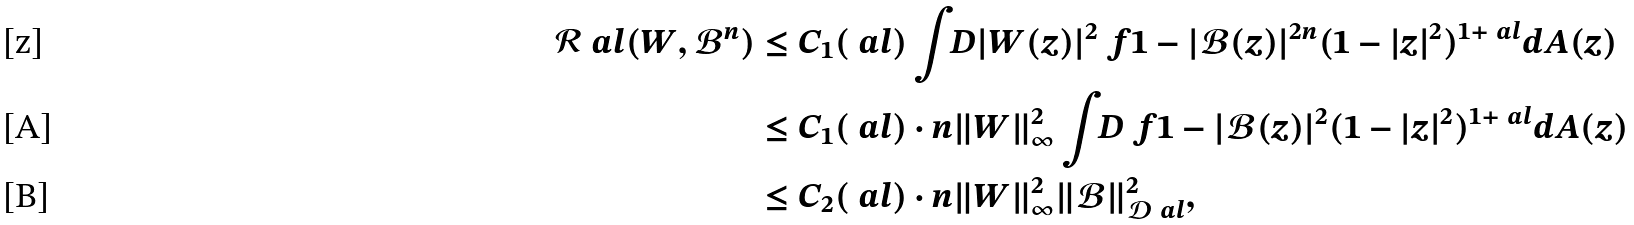Convert formula to latex. <formula><loc_0><loc_0><loc_500><loc_500>\mathcal { R } _ { \ } a l ( W , \mathcal { B } ^ { n } ) & \leq C _ { 1 } ( \ a l ) \int _ { \ } D | W ( z ) | ^ { 2 } \ f { 1 - | \mathcal { B } ( z ) | ^ { 2 n } } { ( 1 - | z | ^ { 2 } ) ^ { 1 + \ a l } } d A ( z ) \\ & \leq C _ { 1 } ( \ a l ) \cdot n \| W \| ^ { 2 } _ { \infty } \int _ { \ } D \ f { 1 - | \mathcal { B } ( z ) | ^ { 2 } } { ( 1 - | z | ^ { 2 } ) ^ { 1 + \ a l } } d A ( z ) \\ & \leq C _ { 2 } ( \ a l ) \cdot n \| W \| ^ { 2 } _ { \infty } \| \mathcal { B } \| ^ { 2 } _ { \mathcal { D } _ { \ } a l } ,</formula> 